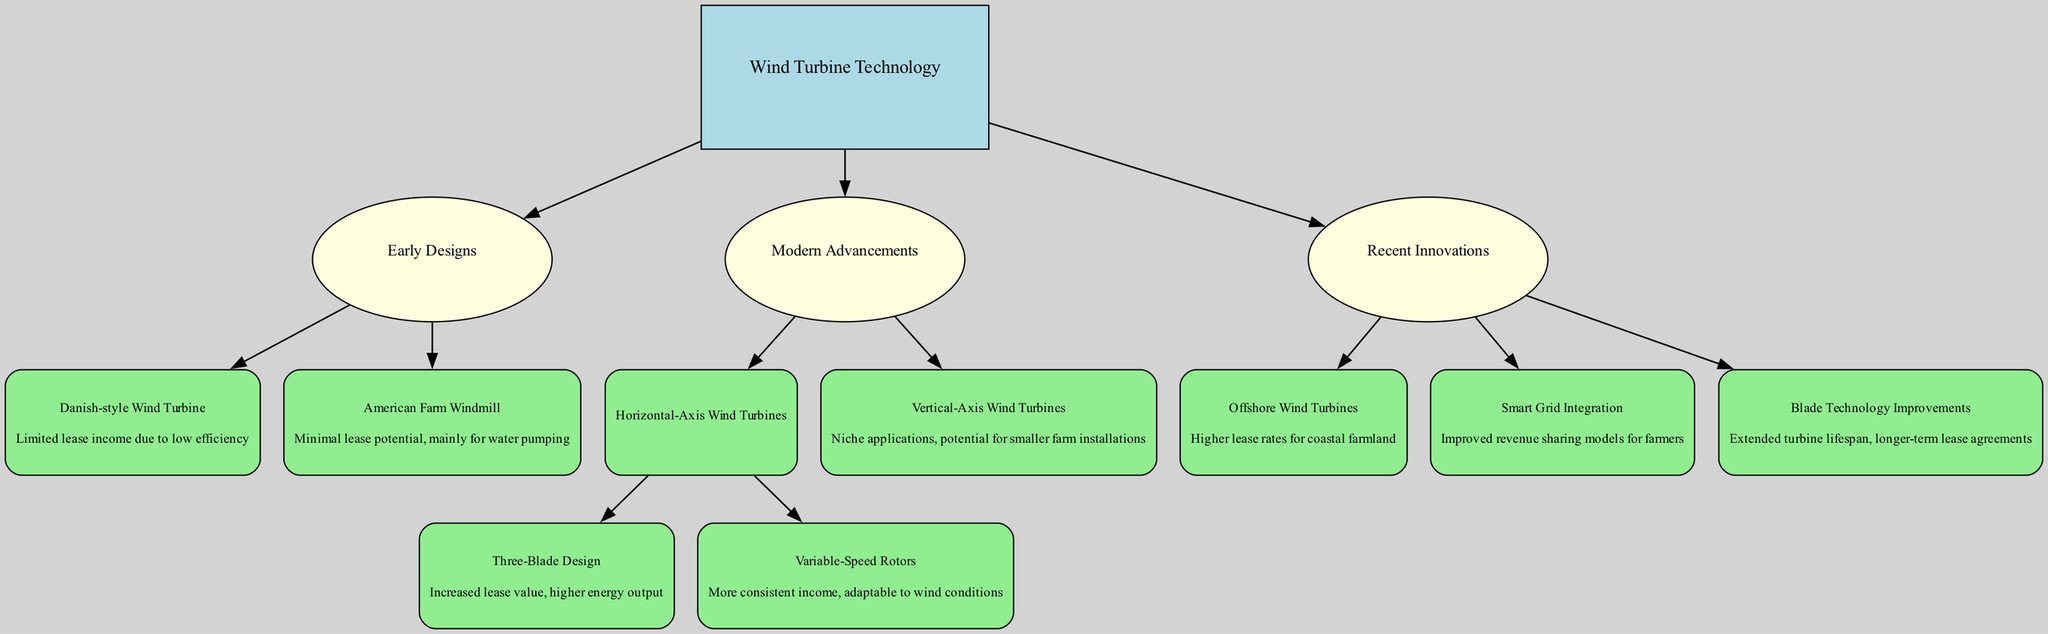What are the two main categories of wind turbine technology? From the diagram, the main categories are "Early Designs" and "Modern Advancements." These are the primary divisions shown in the lineage of wind turbine technology.
Answer: Early Designs, Modern Advancements What impact did the Danish-style wind turbine have on lease income? The diagram states that the impact of the Danish-style wind turbine was "Limited lease income due to low efficiency." Therefore, this is directly stated in the relevant section of the tree.
Answer: Limited lease income due to low efficiency How many impacts are listed under Modern Advancements? In the section labeled Modern Advancements, there are three distinct sub-items: "Horizontal-Axis Wind Turbines," "Vertical-Axis Wind Turbines," and "Recent Innovations." Each of these has its separate impact. Counting these gives a total of three impacts.
Answer: 3 What type of wind turbine is associated with higher lease rates for coastal farmland? By looking at the Recent Innovations section, the impact associated with "Offshore Wind Turbines" indicates they lead to "Higher lease rates for coastal farmland." This connection is clear from the diagram.
Answer: Offshore Wind Turbines How do Variable-Speed Rotors affect the income of a farmer? According to the diagram, they provide "More consistent income, adaptable to wind conditions." This impacts income stability and reliability for farmers.
Answer: More consistent income, adaptable to wind conditions What is the impact of Smart Grid Integration on farmers? The diagram specifies that Smart Grid Integration leads to "Improved revenue sharing models for farmers," indicating a positive financial impact. This information is within the Recent Innovations section.
Answer: Improved revenue sharing models for farmers How many types of Horizontal-Axis Wind Turbines are listed? Under the "Horizontal-Axis Wind Turbines," there are two types mentioned: "Three-Blade Design" and "Variable-Speed Rotors." This leads to a total of two distinct types counted in this category of technology.
Answer: 2 Which wind turbine technology is noted for niche applications? The diagram indicates that "Vertical-Axis Wind Turbines" are recognized for "niche applications." This highlights their specific, less widespread use compared to other technologies.
Answer: Vertical-Axis Wind Turbines 